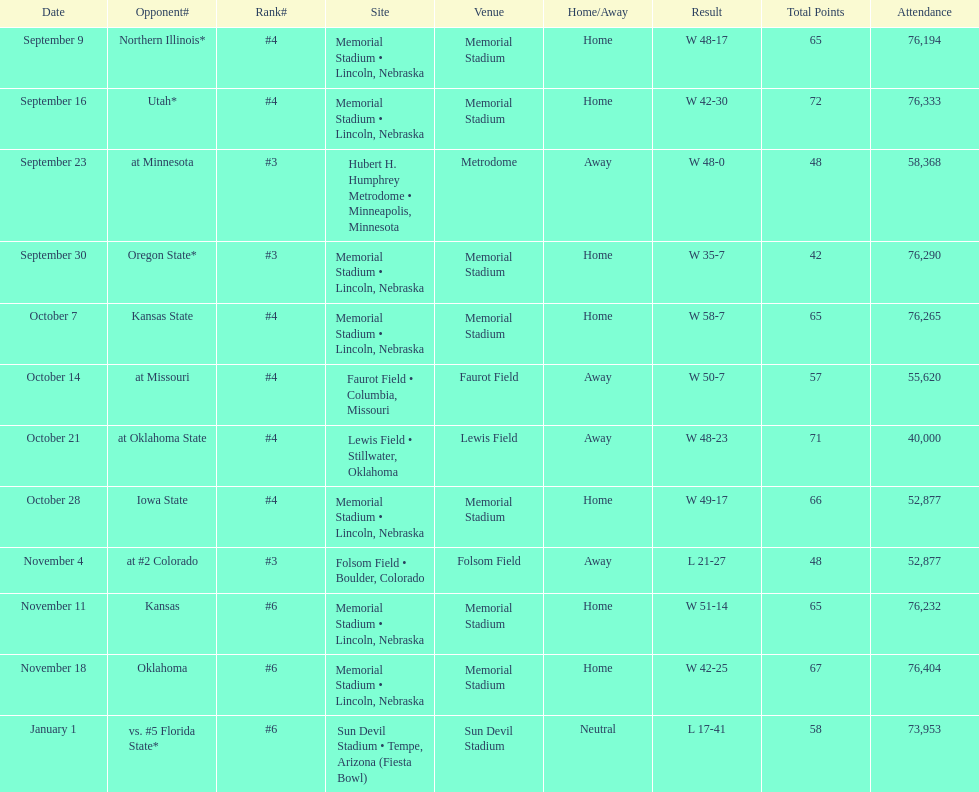How many games was their ranking not lower than #5? 9. 